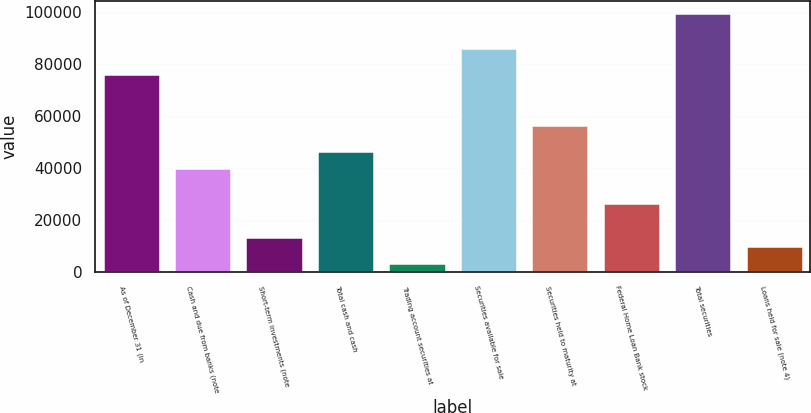<chart> <loc_0><loc_0><loc_500><loc_500><bar_chart><fcel>As of December 31 (in<fcel>Cash and due from banks (note<fcel>Short-term investments (note<fcel>Total cash and cash<fcel>Trading account securities at<fcel>Securities available for sale<fcel>Securities held to maturity at<fcel>Federal Home Loan Bank stock<fcel>Total securities<fcel>Loans held for sale (note 4)<nl><fcel>76386.4<fcel>39855.7<fcel>13287.8<fcel>46497.6<fcel>3324.88<fcel>86349.4<fcel>56460.6<fcel>26571.7<fcel>99633.3<fcel>9966.84<nl></chart> 